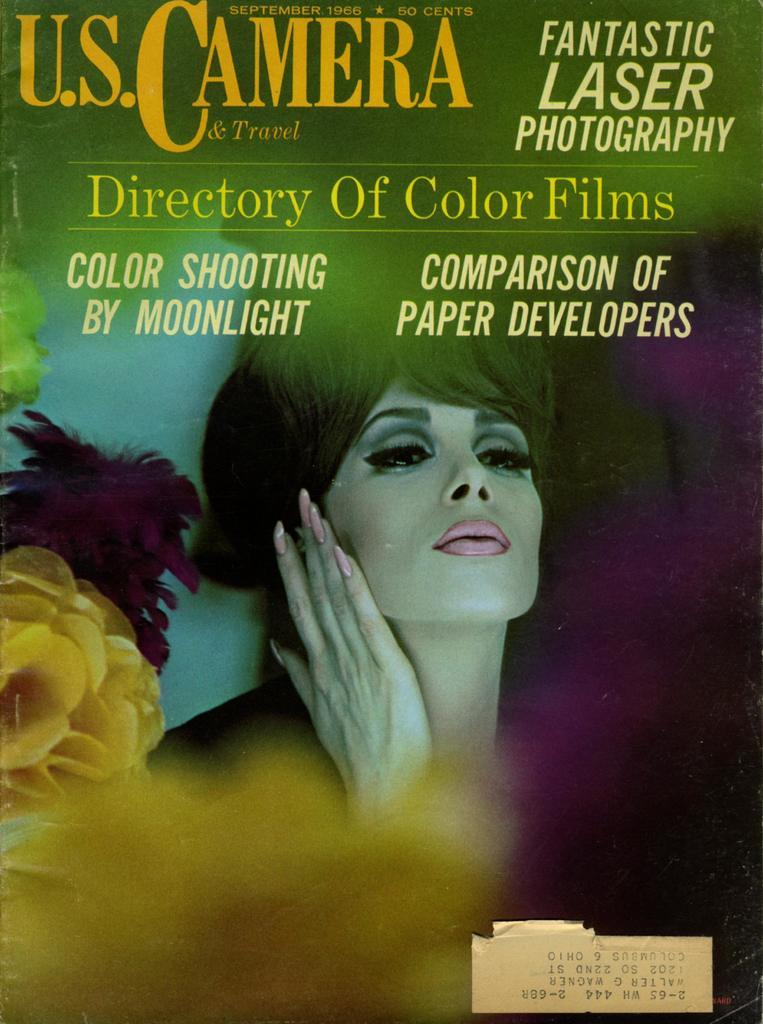What type of visual representation is shown in the image? The image is a poster. Who or what is depicted on the poster? There is a woman depicted on the poster. What other elements are present on the poster besides the woman? There are flowers on the poster. Is there any text on the poster? Yes, text is written on the poster. What type of war is depicted in the image? There is no war depicted in the image; it is a poster featuring a woman, flowers, and text. What country is the woman from in the image? The image does not provide information about the woman's country of origin. 